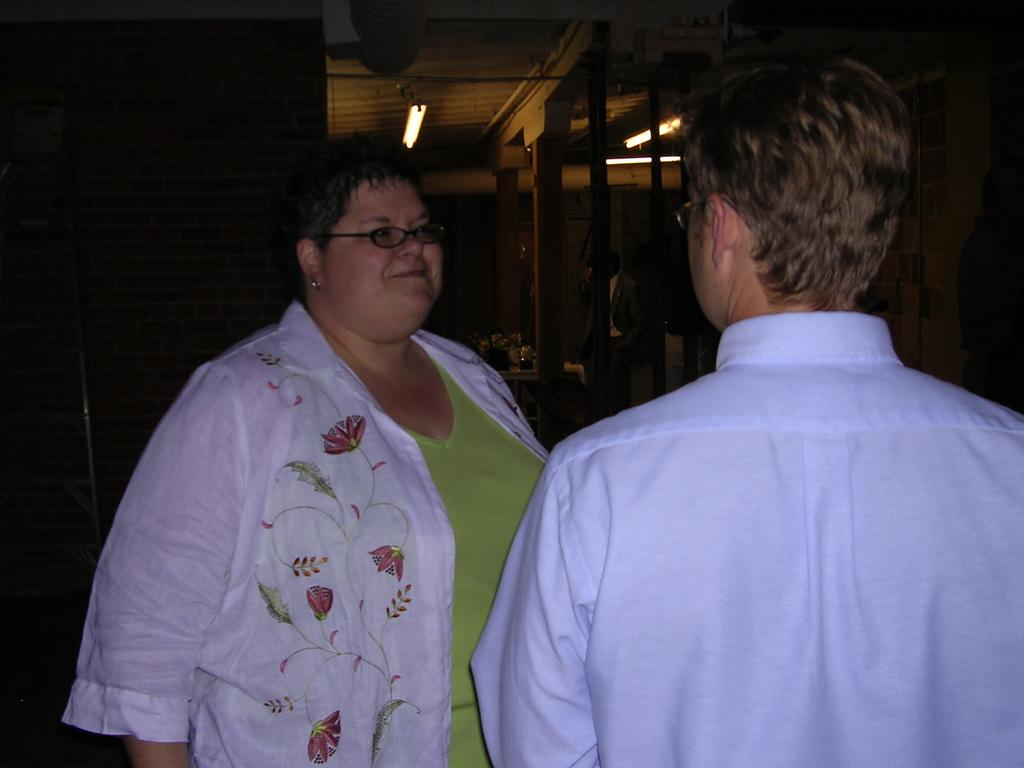Who or what is present in the image? There are people in the image. What can be seen in the background of the image? There are lights visible in the background of the image. What else is on the table in the background of the image? There are other things on the table in the background of the image. What type of parent is depicted in the image? There is no parent present in the image; it only features people. What station is the image taken from? The image is not taken from a station; it is a still image. 